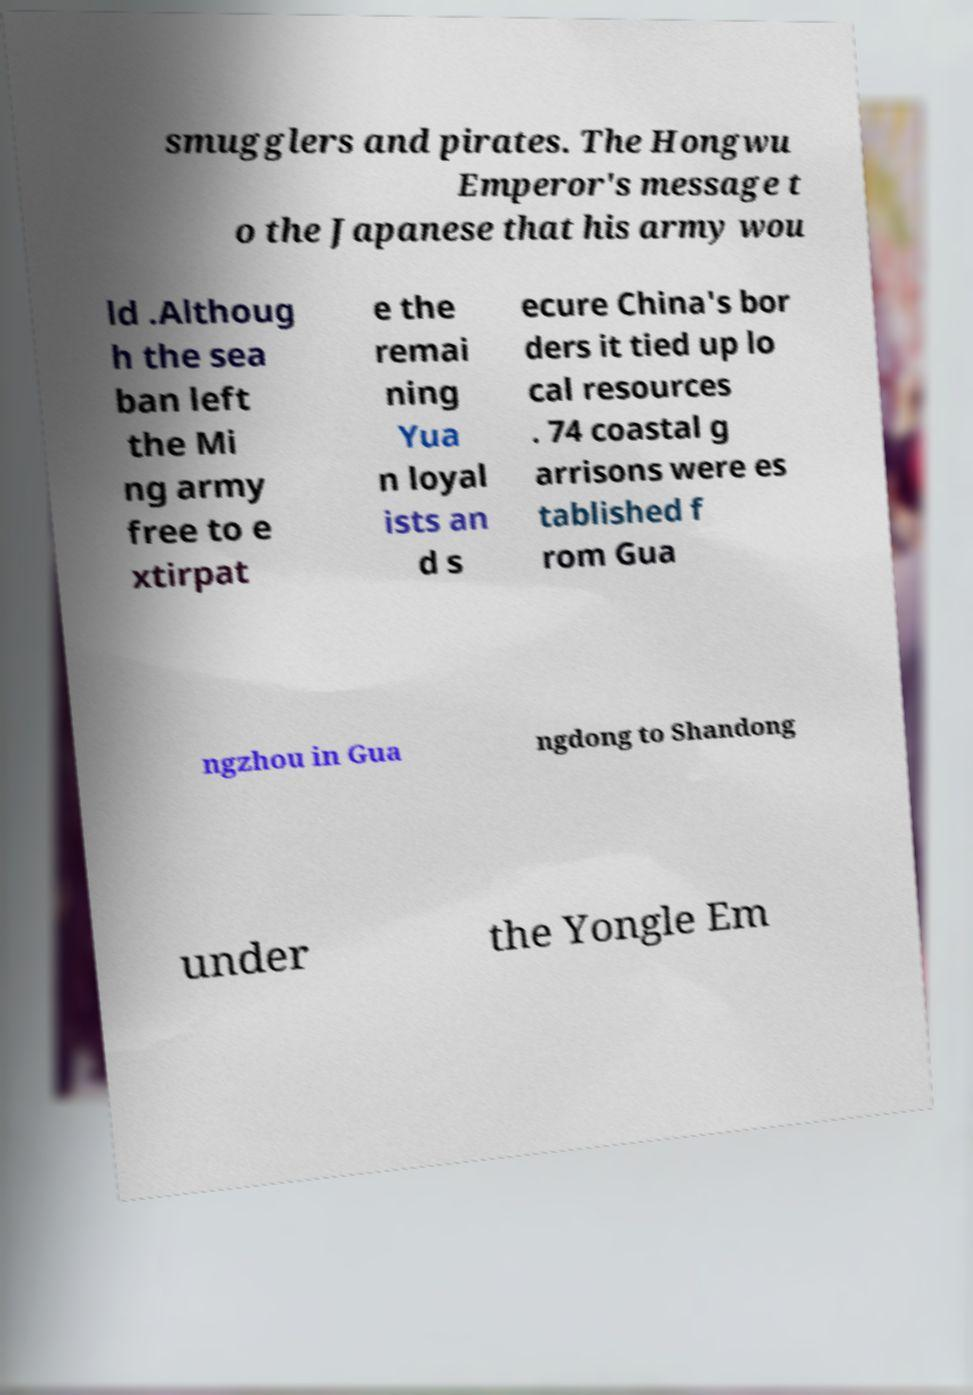Can you read and provide the text displayed in the image?This photo seems to have some interesting text. Can you extract and type it out for me? smugglers and pirates. The Hongwu Emperor's message t o the Japanese that his army wou ld .Althoug h the sea ban left the Mi ng army free to e xtirpat e the remai ning Yua n loyal ists an d s ecure China's bor ders it tied up lo cal resources . 74 coastal g arrisons were es tablished f rom Gua ngzhou in Gua ngdong to Shandong under the Yongle Em 